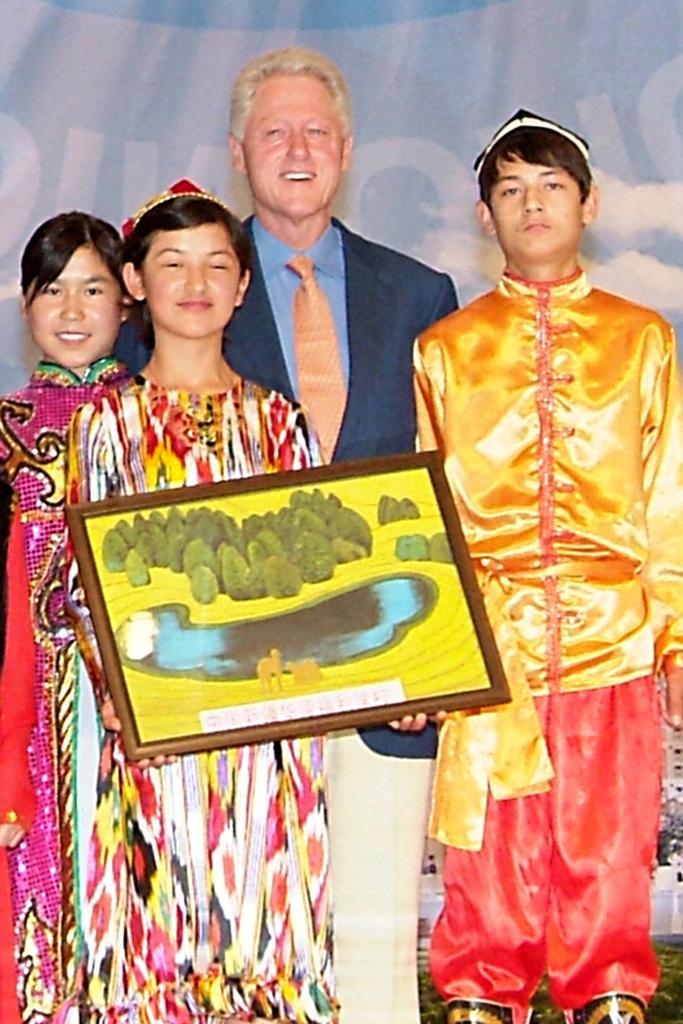Describe this image in one or two sentences. In this image we can see persons standing on the ground and one of them is holding a photo frame in the hands. 